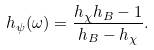Convert formula to latex. <formula><loc_0><loc_0><loc_500><loc_500>h _ { \psi } ( \omega ) = \frac { h _ { \chi } h _ { B } - 1 } { h _ { B } - h _ { \chi } } .</formula> 